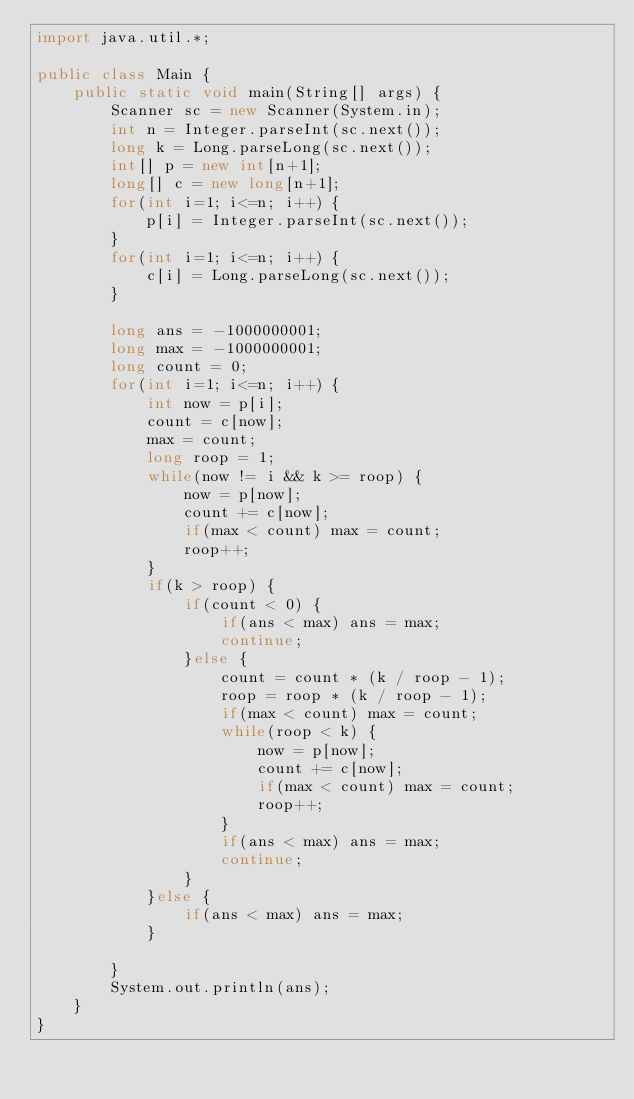<code> <loc_0><loc_0><loc_500><loc_500><_Java_>import java.util.*;
 
public class Main {
    public static void main(String[] args) {
        Scanner sc = new Scanner(System.in);
        int n = Integer.parseInt(sc.next());
        long k = Long.parseLong(sc.next());
        int[] p = new int[n+1];
        long[] c = new long[n+1];
        for(int i=1; i<=n; i++) {
            p[i] = Integer.parseInt(sc.next());
        }
        for(int i=1; i<=n; i++) {
            c[i] = Long.parseLong(sc.next());
        }
        
        long ans = -1000000001;
        long max = -1000000001;
        long count = 0;
        for(int i=1; i<=n; i++) {
            int now = p[i];
            count = c[now];
            max = count;
            long roop = 1;
            while(now != i && k >= roop) {
                now = p[now];
                count += c[now];
                if(max < count) max = count;
                roop++;
            }
            if(k > roop) {
                if(count < 0) {
                    if(ans < max) ans = max;
                    continue;
                }else {
                    count = count * (k / roop - 1);
                    roop = roop * (k / roop - 1);
                    if(max < count) max = count;
                    while(roop < k) {
                        now = p[now];
                        count += c[now];
                        if(max < count) max = count;
                        roop++;
                    }
                    if(ans < max) ans = max;
                    continue;
                }
            }else {
                if(ans < max) ans = max;
            }
            
        }
        System.out.println(ans);
    }
}</code> 